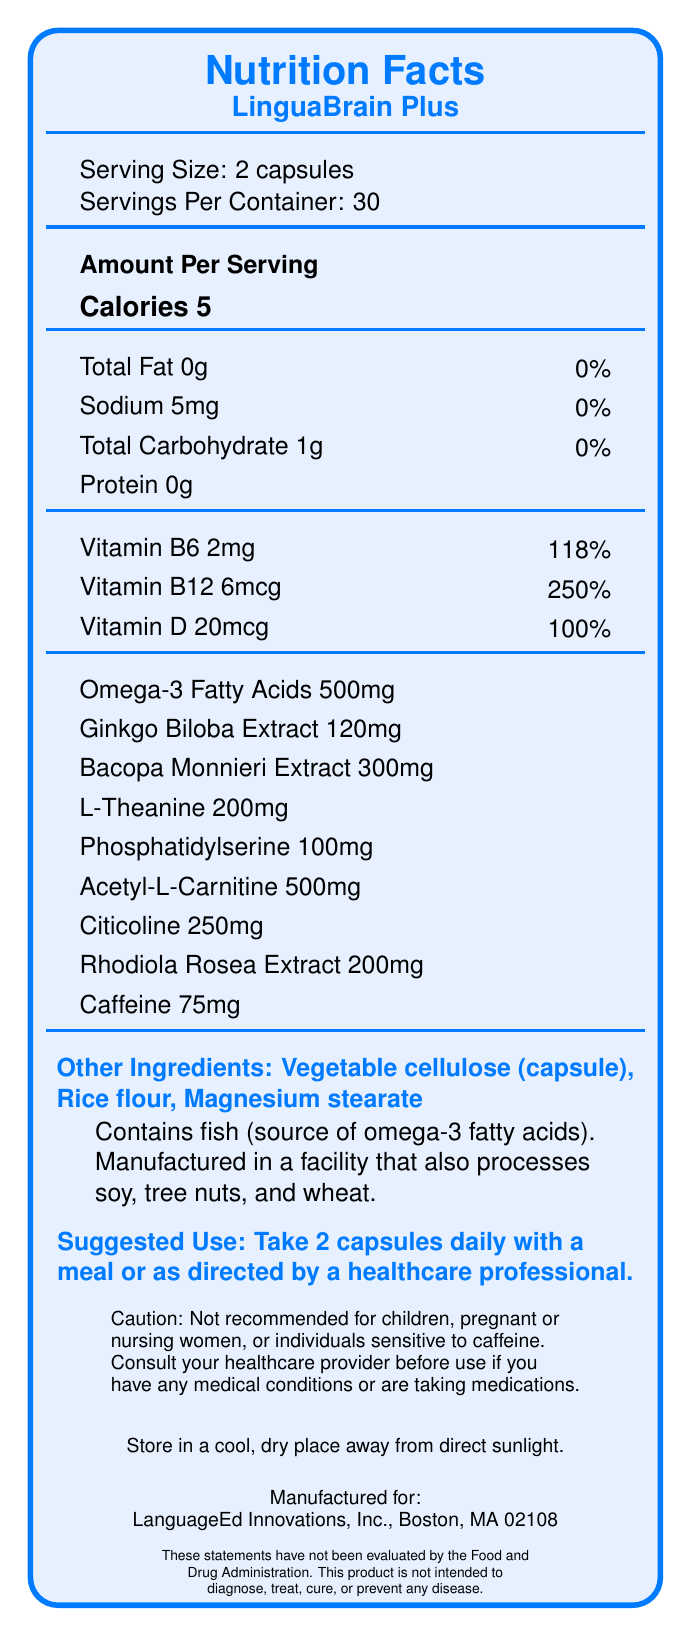what is the serving size? The document states that the serving size is 2 capsules.
Answer: 2 capsules how many servings per container are available? The document mentions that there are 30 servings per container.
Answer: 30 how many calories are in each serving? The document lists 5 calories per serving.
Answer: 5 calories what percentage of daily value is vitamin b12 in this supplement? According to the document, vitamin B12 covers 250% of the daily value per serving.
Answer: 250% which ingredient is present in the largest quantity: omega-3 fatty acids, ginkgo biloba extract, or citicoline? The document shows that omega-3 fatty acids are present at 500mg, which is larger than ginkgo biloba extract (120mg) and citicoline (250mg).
Answer: Omega-3 fatty acids what is the source of omega-3 fatty acids in this product? The document states that the omega-3 fatty acids are sourced from fish.
Answer: Fish what is the caution given about caffeine? The document advises that individuals who are sensitive to caffeine should not use the supplement.
Answer: Not recommended for individuals sensitive to caffeine how much acetyl-l-carnitine is present in each serving? The document specifies that there are 500 mg of acetyl-l-carnitine per serving.
Answer: 500 mg what are the suggested usage instructions for this supplement? The document provides these instructions under “Suggested Use”.
Answer: Take 2 capsules daily with a meal or as directed by a healthcare professional what organization manufactures lingua brain plus? The document states that LanguageEd Innovations, Inc., Boston, MA 02108 manufactures the product.
Answer: LanguageEd Innovations, Inc., Boston, MA 02108 which of the following is not an ingredient in lingua brain plus? A. Rice flour B. Magnesium stearate C. Soy protein D. Vegetable cellulose The document lists rice flour, magnesium stearate, and vegetable cellulose but does not list soy protein as an ingredient.
Answer: C. Soy protein where should the supplement be stored? A. In a warm place B. In a cool, dry place away from direct sunlight C. In the refrigerator The document specifies to store the supplement in a cool, dry place away from direct sunlight.
Answer: B. In a cool, dry place away from direct sunlight can this supplement be taken by children? The caution section clearly states it is not recommended for children.
Answer: No what are the educational benefits of lingua brain plus? The document lists these benefits under Educational Benefits.
Answer: Supports memory retention, enhances focus, promotes mental clarity, and boosts cognitive stamina is ammonia an ingredient in lingua brain plus? The document does not mention ammonia as an ingredient.
Answer: No what allergens are present in this supplement? The document states that the product contains fish, which is the source of omega-3 fatty acids.
Answer: Fish what organization evaluates the statements about this product? The document contains a disclaimer stating that the statements have not been evaluated by the Food and Drug Administration, but it does not specify an organization that evaluates them.
Answer: Cannot be determined summarize the nutritional information and key features of lingua brain plus. The document provides detailed nutritional information, including amounts of each ingredient, allergens, suggested use, and cautions. It aims to support memory, focus, mental clarity, and cognitive stamina, mainly for language learners and related professionals.
Answer: LinguaBrain Plus is a brain-boosting supplement designed for cognitive function. Each serving size is 2 capsules with 30 servings per container, containing 5 calories. It includes vitamins (B6, B12, D), omega-3 fatty acids, ginkgo biloba, bacopa monnieri, and several other ingredients targeted at enhancing brain functions. Suggested use is 2 capsules daily, and it includes cautions such as not recommended for children or pregnant/nursing women. 